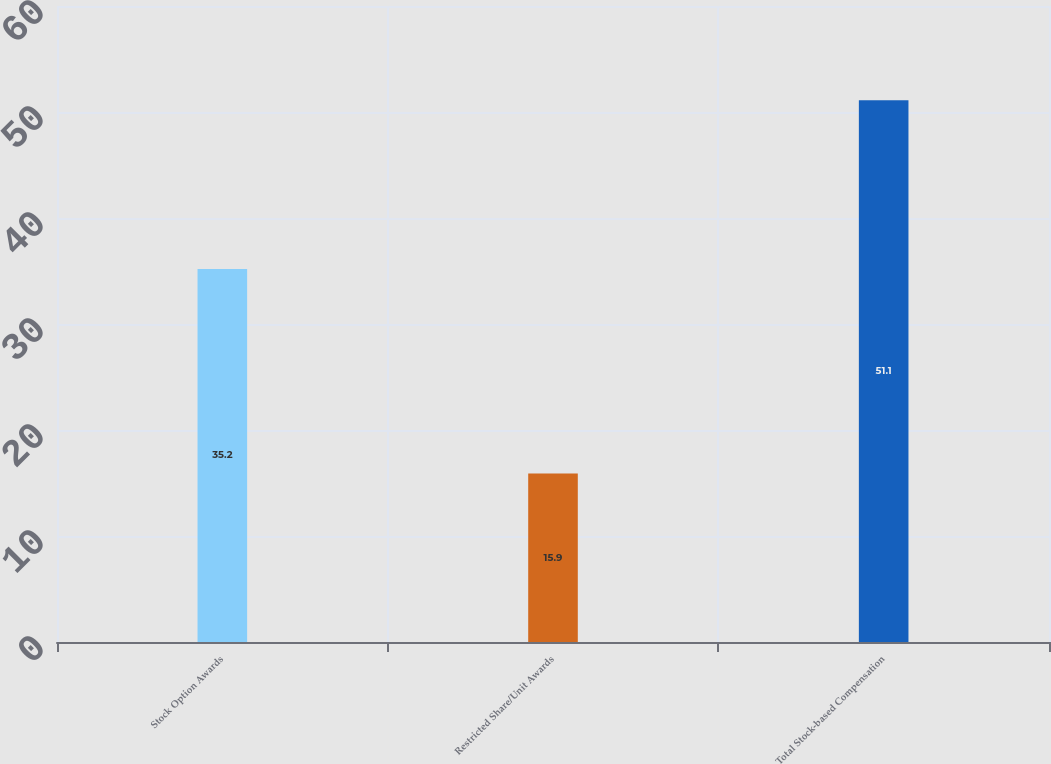Convert chart to OTSL. <chart><loc_0><loc_0><loc_500><loc_500><bar_chart><fcel>Stock Option Awards<fcel>Restricted Share/Unit Awards<fcel>Total Stock-based Compensation<nl><fcel>35.2<fcel>15.9<fcel>51.1<nl></chart> 